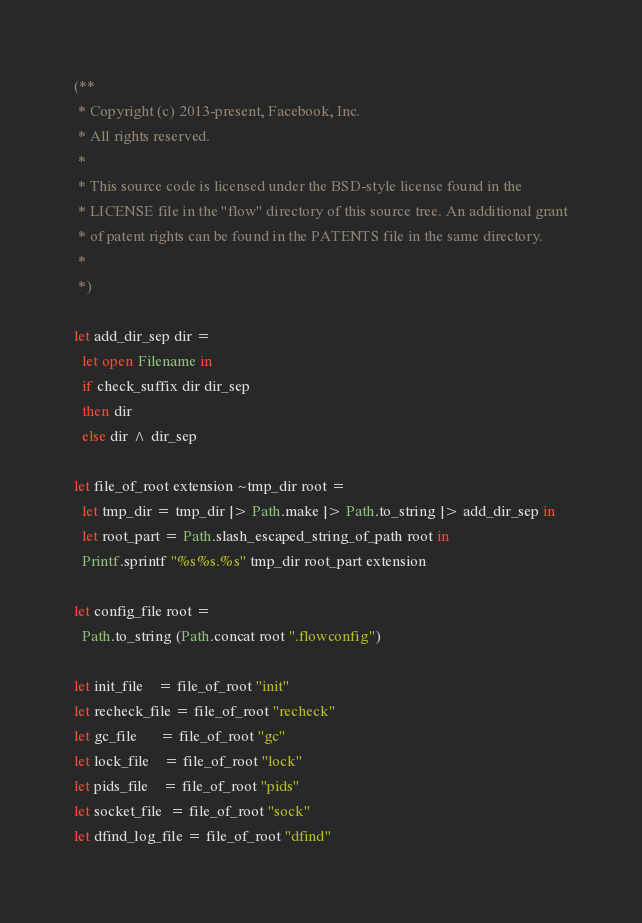<code> <loc_0><loc_0><loc_500><loc_500><_OCaml_>(**
 * Copyright (c) 2013-present, Facebook, Inc.
 * All rights reserved.
 *
 * This source code is licensed under the BSD-style license found in the
 * LICENSE file in the "flow" directory of this source tree. An additional grant
 * of patent rights can be found in the PATENTS file in the same directory.
 *
 *)

let add_dir_sep dir =
  let open Filename in
  if check_suffix dir dir_sep
  then dir
  else dir ^ dir_sep

let file_of_root extension ~tmp_dir root =
  let tmp_dir = tmp_dir |> Path.make |> Path.to_string |> add_dir_sep in
  let root_part = Path.slash_escaped_string_of_path root in
  Printf.sprintf "%s%s.%s" tmp_dir root_part extension

let config_file root =
  Path.to_string (Path.concat root ".flowconfig")

let init_file    = file_of_root "init"
let recheck_file = file_of_root "recheck"
let gc_file      = file_of_root "gc"
let lock_file    = file_of_root "lock"
let pids_file    = file_of_root "pids"
let socket_file  = file_of_root "sock"
let dfind_log_file = file_of_root "dfind"
</code> 